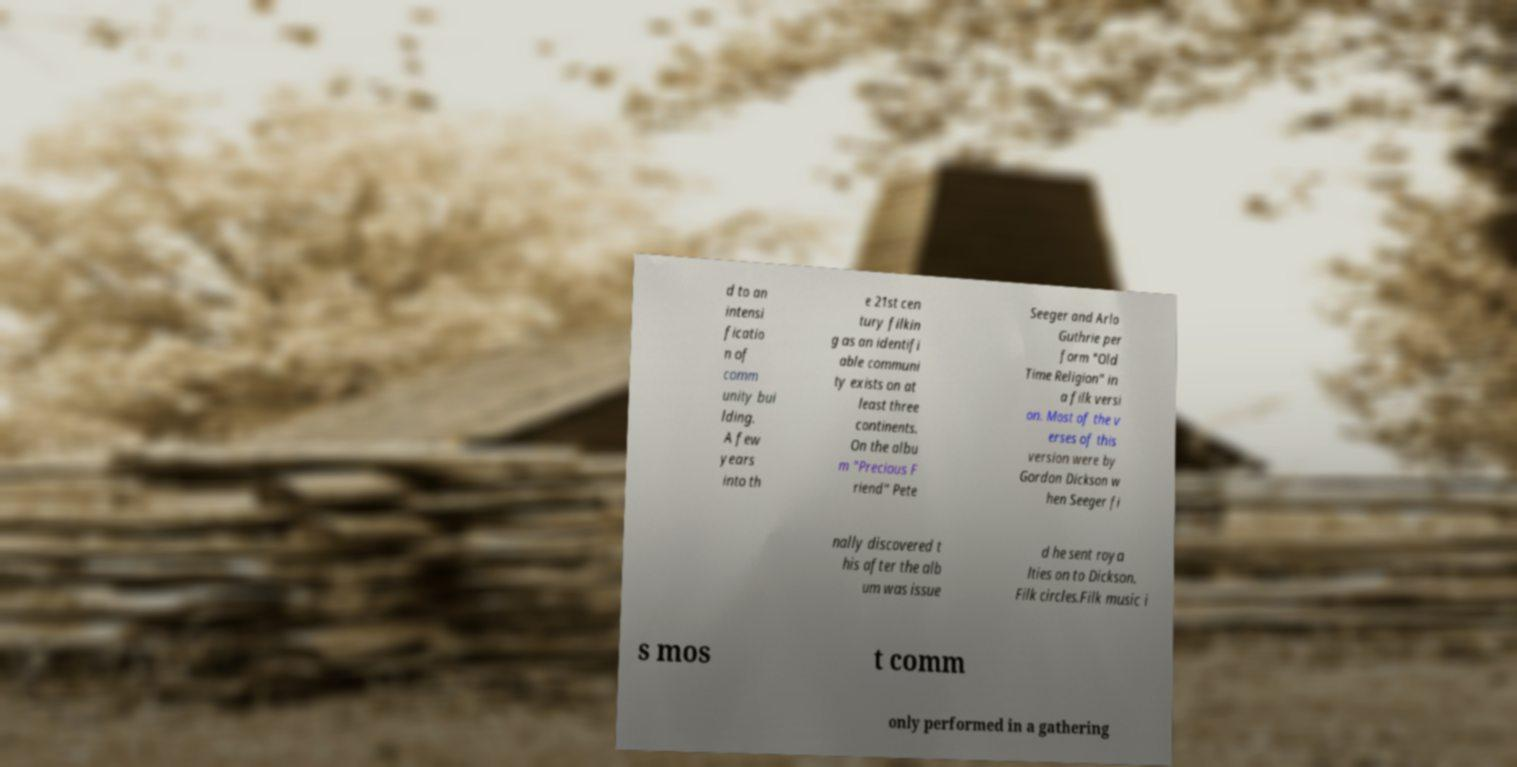I need the written content from this picture converted into text. Can you do that? d to an intensi ficatio n of comm unity bui lding. A few years into th e 21st cen tury filkin g as an identifi able communi ty exists on at least three continents. On the albu m "Precious F riend" Pete Seeger and Arlo Guthrie per form "Old Time Religion" in a filk versi on. Most of the v erses of this version were by Gordon Dickson w hen Seeger fi nally discovered t his after the alb um was issue d he sent roya lties on to Dickson. Filk circles.Filk music i s mos t comm only performed in a gathering 